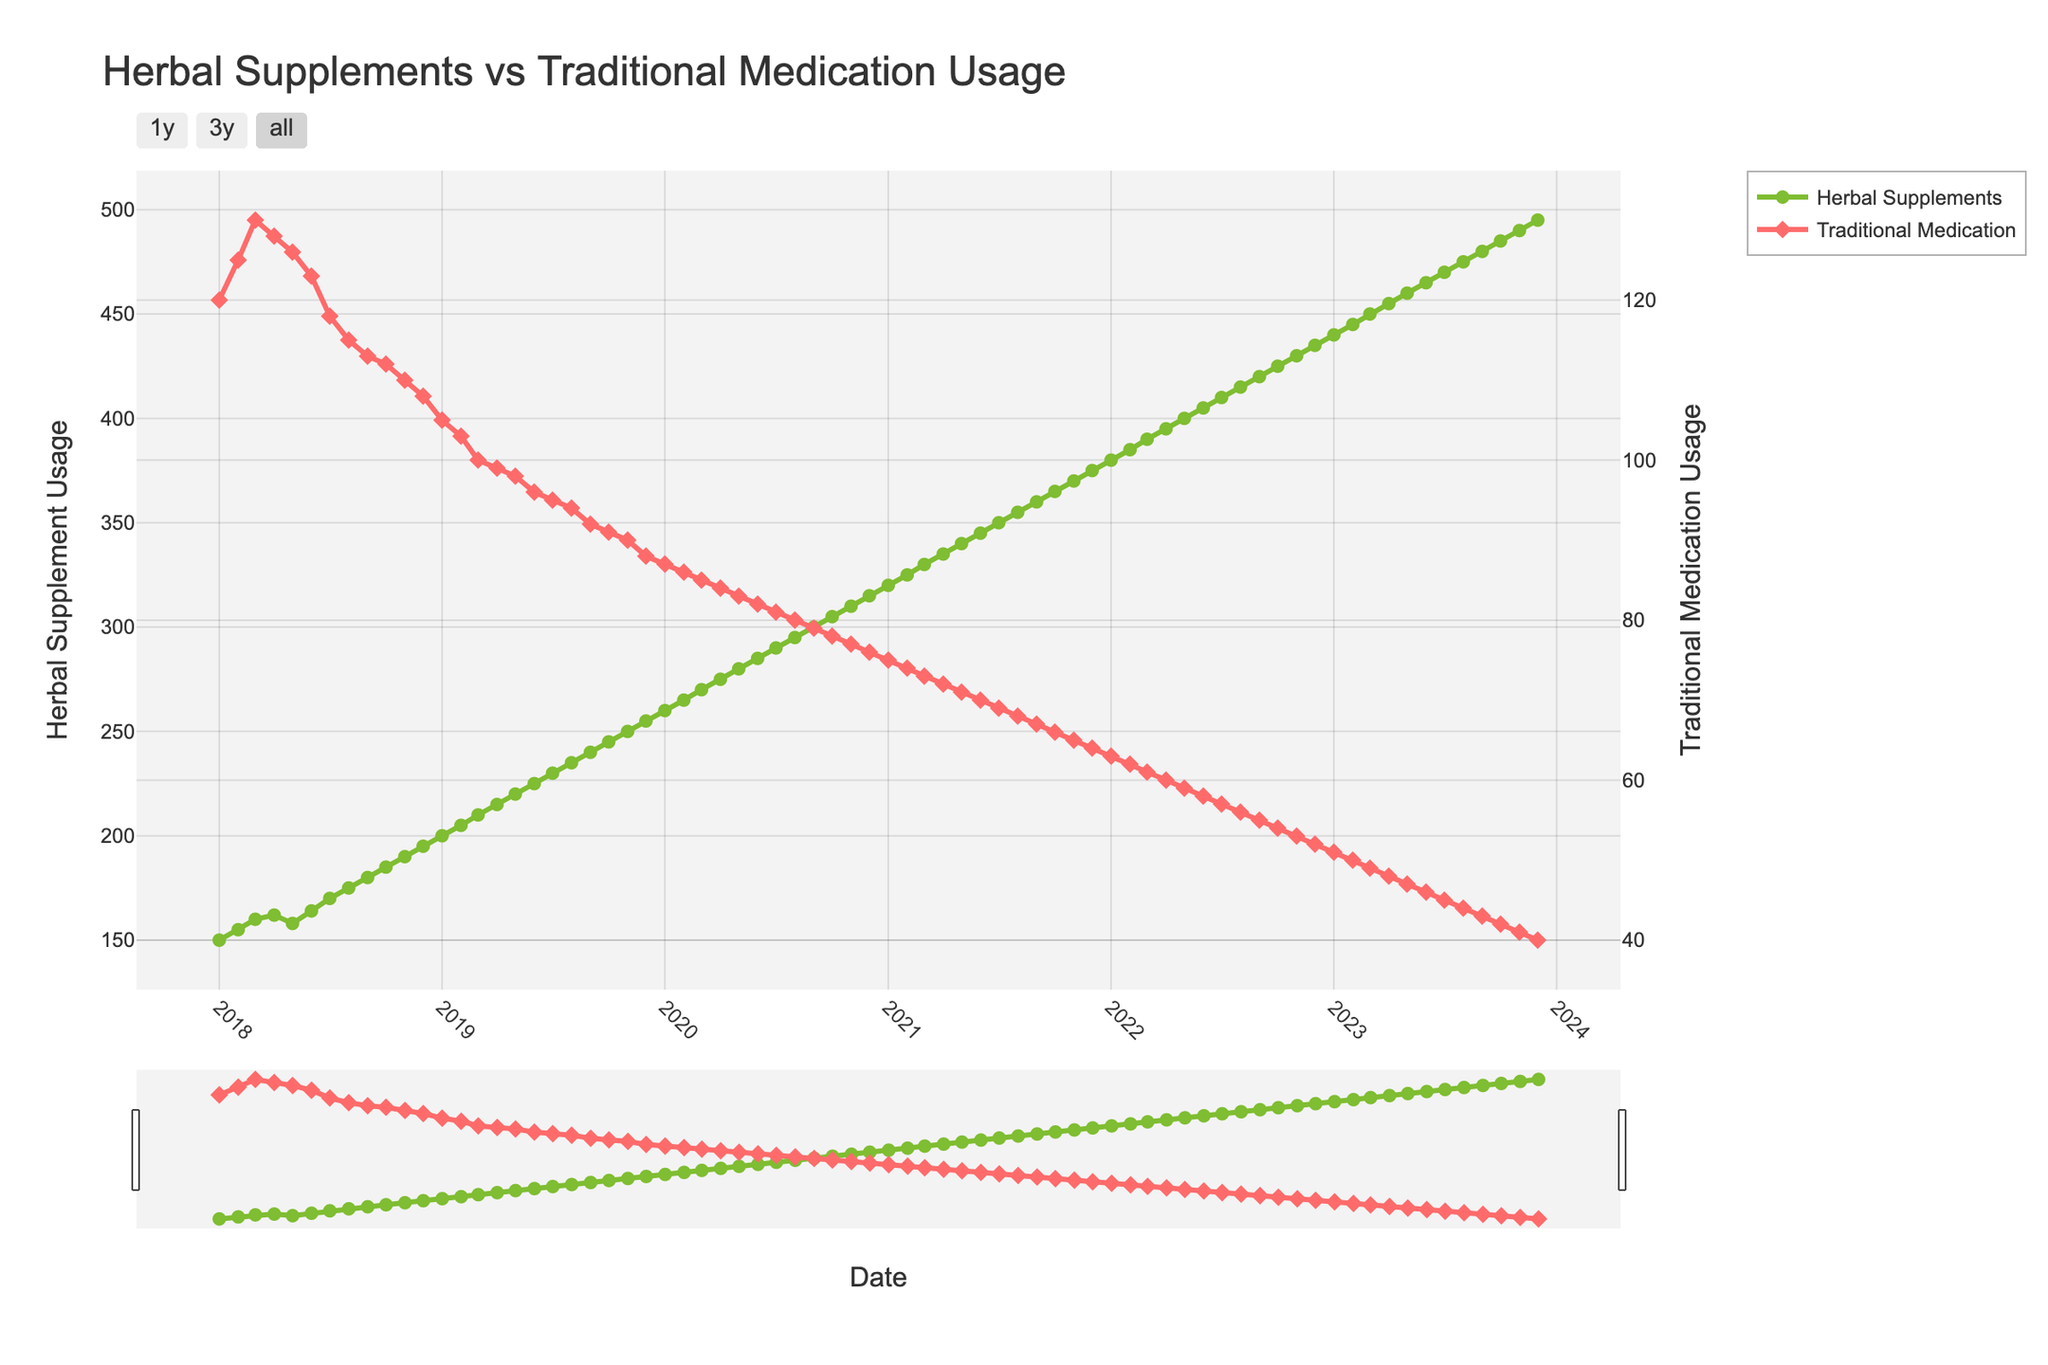What's the title of the figure? The title of the figure is displayed at the top and reads "Herbal Supplements vs Traditional Medication Usage".
Answer: Herbal Supplements vs Traditional Medication Usage What are the y-axes titles? The y-axis on the left is titled "Herbal Supplement Usage" and the y-axis on the right is titled "Traditional Medication Usage".
Answer: Herbal Supplement Usage, Traditional Medication Usage What colors represent herbal supplement usage and traditional medication usage? The herbal supplement usage line is green, and the traditional medication usage line is red.
Answer: green, red Which month and year has the highest usage of herbal supplements? The graph shows a continuous increase in herbal supplement usage, peaking in December 2023.
Answer: December 2023 How does the trend in traditional medication usage change over the period? The trend in traditional medication usage consistently decreases over the entire period from January 2018 to December 2023.
Answer: consistently decreases What was the herbal supplement usage in June 2020? To find the herbal supplement usage for June 2020, locate the corresponding point on the curve. The value for June 2020 is 285.
Answer: 285 In December 2018, what is the difference in usage between herbal supplements and traditional medication? Find the values for both herbal supplements (195) and traditional medication (108) for December 2018 and subtract the latter from the former. The difference is 195 - 108 = 87.
Answer: 87 What is the average herbal supplement usage for the year 2022? Sum the values for each month in 2022 and divide by 12. The values are: 380, 385, 390, 395, 400, 405, 410, 415, 420, 425, 430, and 435. The sum is 4910, and the average is 4910 / 12 = 409.17.
Answer: 409.17 Compare the herbal supplement usage in January 2020 and January 2021. Which is higher and by how much? January 2020 has an herbal supplement usage of 260, whereas January 2021 has 320. The increment is 320 - 260 = 60.
Answer: 2021 is higher by 60 What is the overall trend in herbal supplement usage from 2018 to 2023? The overall trend in herbal supplement usage is a consistent increase from January 2018 to December 2023.
Answer: consistent increase 